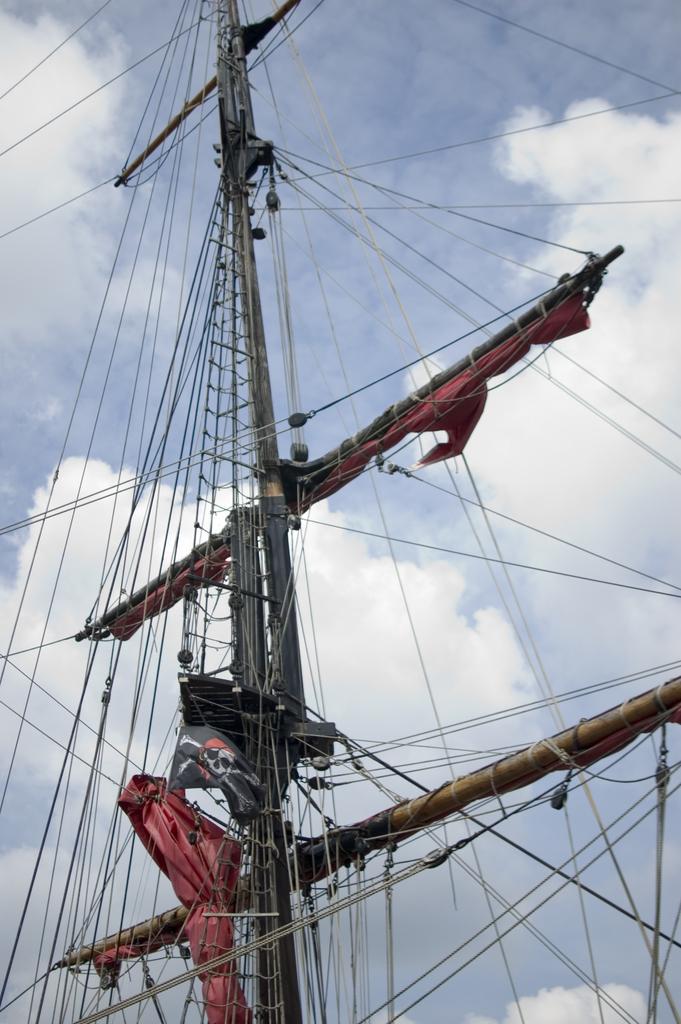Can you describe this image briefly? In this picture I can see there is a brig and it has ropes attached here and the sky is clear. 